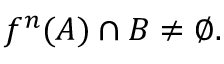Convert formula to latex. <formula><loc_0><loc_0><loc_500><loc_500>f ^ { n } ( A ) \cap B \neq \varnothing .</formula> 